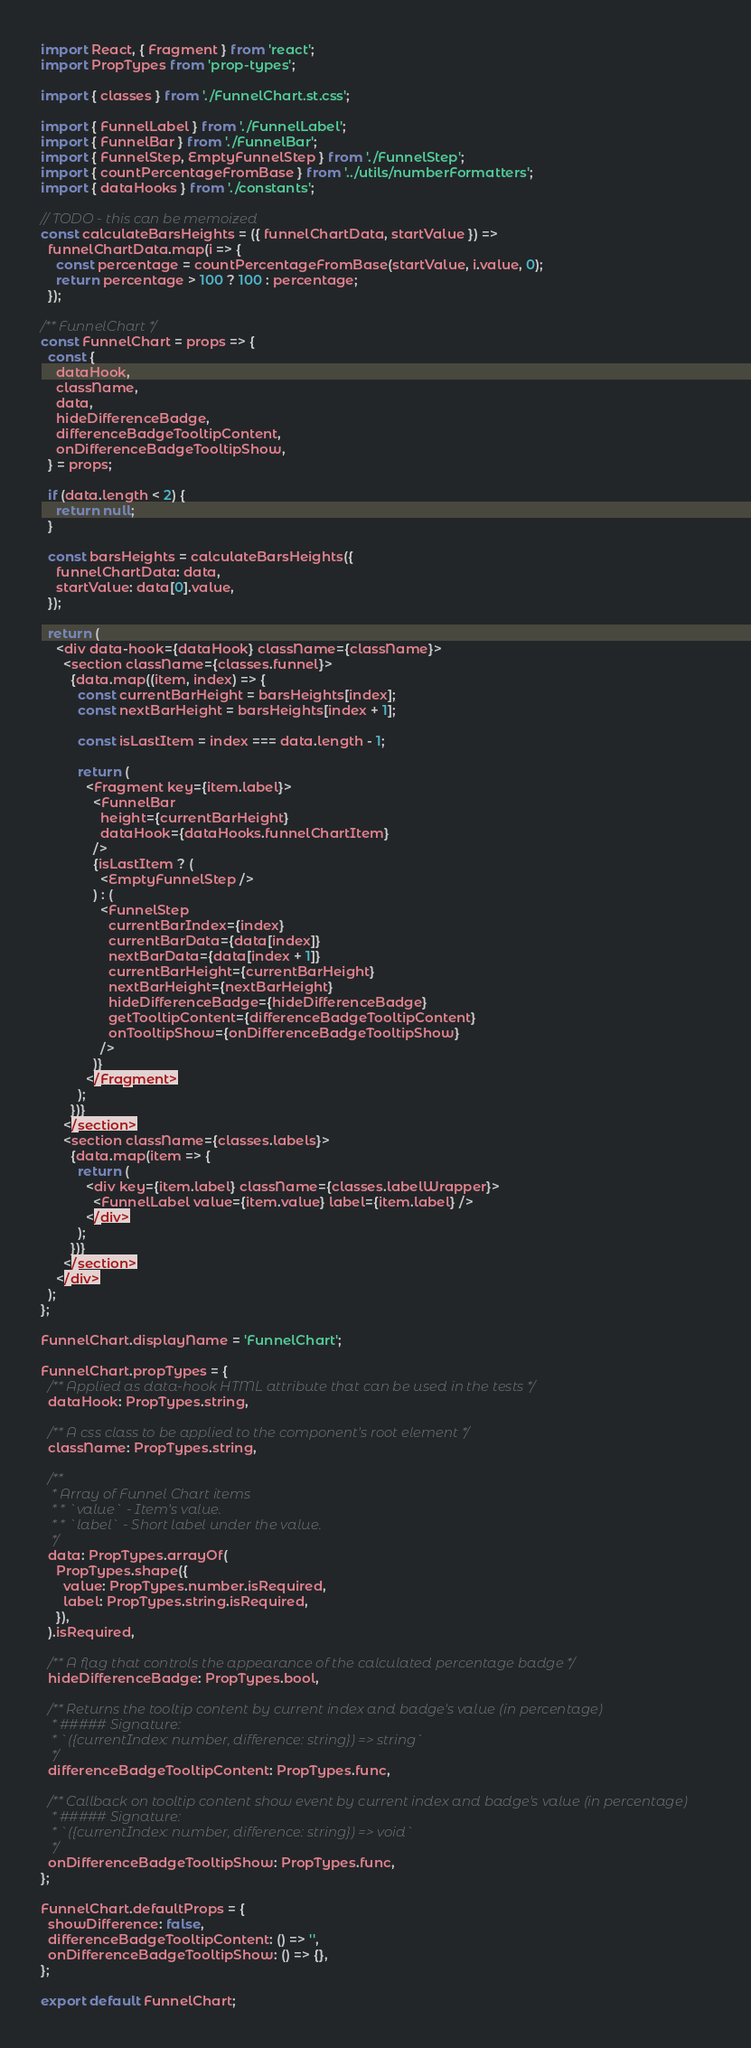<code> <loc_0><loc_0><loc_500><loc_500><_JavaScript_>import React, { Fragment } from 'react';
import PropTypes from 'prop-types';

import { classes } from './FunnelChart.st.css';

import { FunnelLabel } from './FunnelLabel';
import { FunnelBar } from './FunnelBar';
import { FunnelStep, EmptyFunnelStep } from './FunnelStep';
import { countPercentageFromBase } from '../utils/numberFormatters';
import { dataHooks } from './constants';

// TODO - this can be memoized
const calculateBarsHeights = ({ funnelChartData, startValue }) =>
  funnelChartData.map(i => {
    const percentage = countPercentageFromBase(startValue, i.value, 0);
    return percentage > 100 ? 100 : percentage;
  });

/** FunnelChart */
const FunnelChart = props => {
  const {
    dataHook,
    className,
    data,
    hideDifferenceBadge,
    differenceBadgeTooltipContent,
    onDifferenceBadgeTooltipShow,
  } = props;

  if (data.length < 2) {
    return null;
  }

  const barsHeights = calculateBarsHeights({
    funnelChartData: data,
    startValue: data[0].value,
  });

  return (
    <div data-hook={dataHook} className={className}>
      <section className={classes.funnel}>
        {data.map((item, index) => {
          const currentBarHeight = barsHeights[index];
          const nextBarHeight = barsHeights[index + 1];

          const isLastItem = index === data.length - 1;

          return (
            <Fragment key={item.label}>
              <FunnelBar
                height={currentBarHeight}
                dataHook={dataHooks.funnelChartItem}
              />
              {isLastItem ? (
                <EmptyFunnelStep />
              ) : (
                <FunnelStep
                  currentBarIndex={index}
                  currentBarData={data[index]}
                  nextBarData={data[index + 1]}
                  currentBarHeight={currentBarHeight}
                  nextBarHeight={nextBarHeight}
                  hideDifferenceBadge={hideDifferenceBadge}
                  getTooltipContent={differenceBadgeTooltipContent}
                  onTooltipShow={onDifferenceBadgeTooltipShow}
                />
              )}
            </Fragment>
          );
        })}
      </section>
      <section className={classes.labels}>
        {data.map(item => {
          return (
            <div key={item.label} className={classes.labelWrapper}>
              <FunnelLabel value={item.value} label={item.label} />
            </div>
          );
        })}
      </section>
    </div>
  );
};

FunnelChart.displayName = 'FunnelChart';

FunnelChart.propTypes = {
  /** Applied as data-hook HTML attribute that can be used in the tests */
  dataHook: PropTypes.string,

  /** A css class to be applied to the component's root element */
  className: PropTypes.string,

  /**
   * Array of Funnel Chart items
   * * `value` - Item's value.
   * * `label` - Short label under the value.
   */
  data: PropTypes.arrayOf(
    PropTypes.shape({
      value: PropTypes.number.isRequired,
      label: PropTypes.string.isRequired,
    }),
  ).isRequired,

  /** A flag that controls the appearance of the calculated percentage badge */
  hideDifferenceBadge: PropTypes.bool,

  /** Returns the tooltip content by current index and badge's value (in percentage)
   * ##### Signature:
   * `({currentIndex: number, difference: string}) => string`
   */
  differenceBadgeTooltipContent: PropTypes.func,

  /** Callback on tooltip content show event by current index and badge's value (in percentage)
   * ##### Signature:
   * `({currentIndex: number, difference: string}) => void`
   */
  onDifferenceBadgeTooltipShow: PropTypes.func,
};

FunnelChart.defaultProps = {
  showDifference: false,
  differenceBadgeTooltipContent: () => '',
  onDifferenceBadgeTooltipShow: () => {},
};

export default FunnelChart;
</code> 